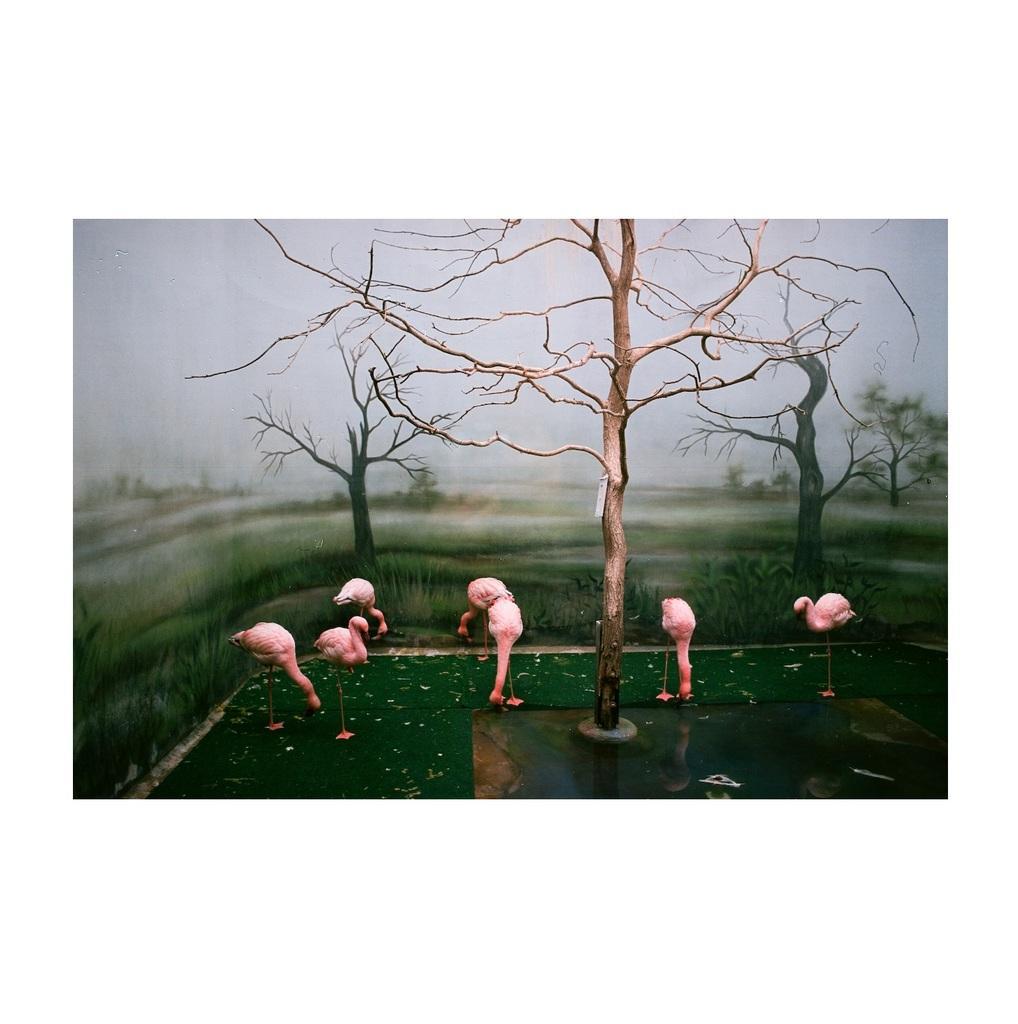How would you summarize this image in a sentence or two? In the foreground of the picture there are flamingos, trees, grass and water. Sky is cloudy. The background is blurred. 